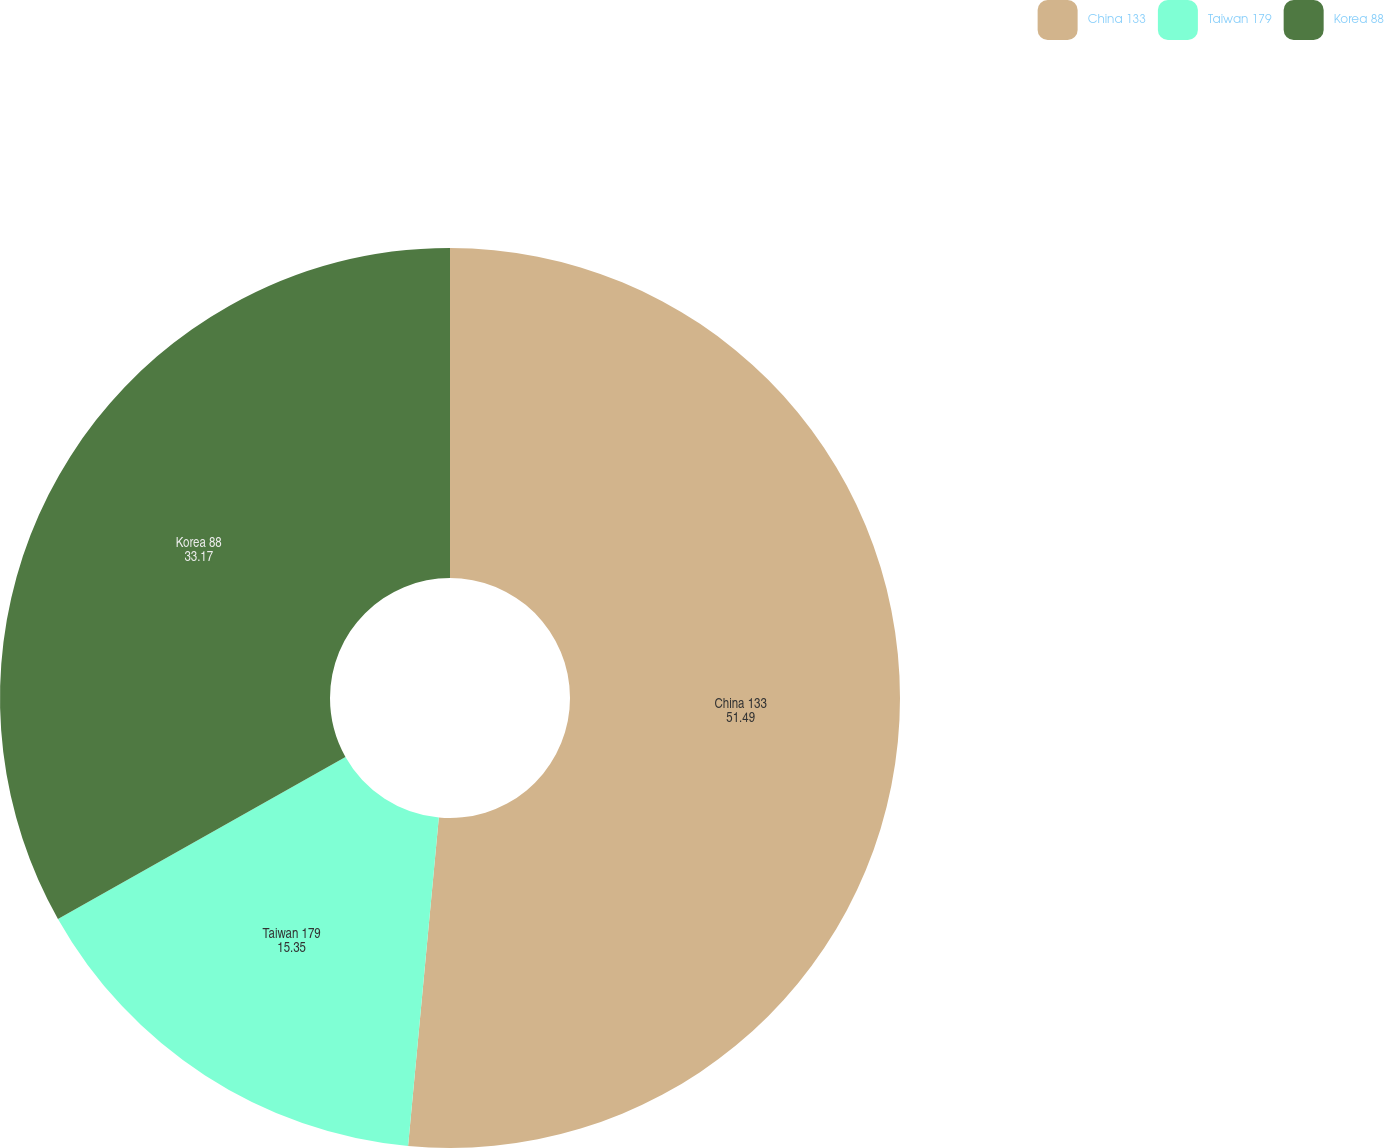Convert chart to OTSL. <chart><loc_0><loc_0><loc_500><loc_500><pie_chart><fcel>China 133<fcel>Taiwan 179<fcel>Korea 88<nl><fcel>51.49%<fcel>15.35%<fcel>33.17%<nl></chart> 